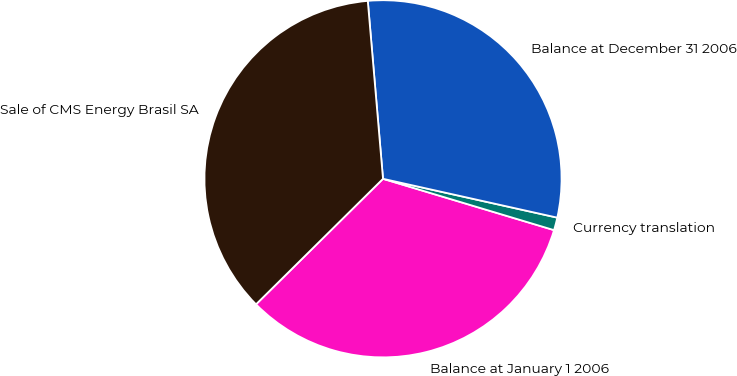Convert chart to OTSL. <chart><loc_0><loc_0><loc_500><loc_500><pie_chart><fcel>Balance at January 1 2006<fcel>Currency translation<fcel>Balance at December 31 2006<fcel>Sale of CMS Energy Brasil SA<nl><fcel>32.95%<fcel>1.15%<fcel>29.85%<fcel>36.05%<nl></chart> 